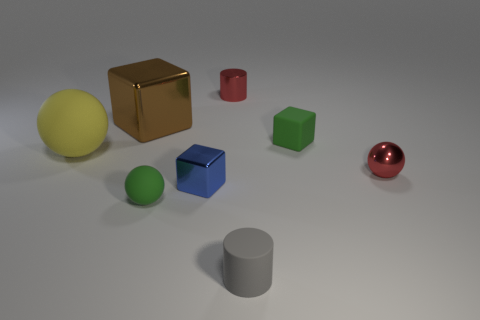There is a green rubber thing that is left of the gray cylinder; does it have the same size as the yellow ball?
Your answer should be compact. No. What is the shape of the green matte object in front of the tiny ball that is to the right of the small green matte block?
Provide a short and direct response. Sphere. How big is the matte ball left of the rubber ball that is in front of the large ball?
Provide a short and direct response. Large. The cylinder that is in front of the green rubber cube is what color?
Make the answer very short. Gray. What is the size of the yellow sphere that is made of the same material as the green ball?
Give a very brief answer. Large. How many tiny green matte things are the same shape as the yellow rubber object?
Your response must be concise. 1. There is a blue block that is the same size as the shiny ball; what is its material?
Provide a short and direct response. Metal. Is there a small gray object that has the same material as the tiny green cube?
Make the answer very short. Yes. What is the color of the thing that is left of the tiny red shiny cylinder and behind the small rubber cube?
Keep it short and to the point. Brown. What number of other objects are the same color as the metallic cylinder?
Provide a succinct answer. 1. 